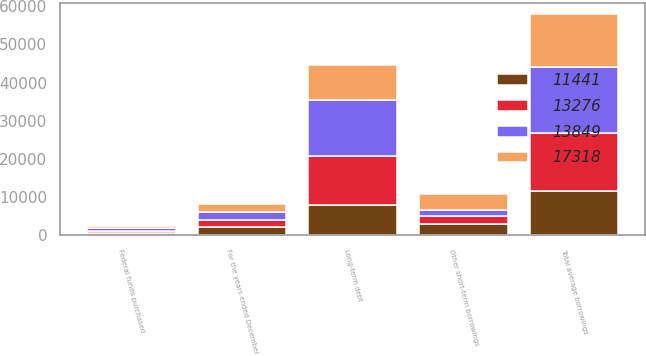Convert chart to OTSL. <chart><loc_0><loc_0><loc_500><loc_500><stacked_bar_chart><ecel><fcel>For the years ended December<fcel>Federal funds purchased<fcel>Other short-term borrowings<fcel>Long-term debt<fcel>Total average borrowings<nl><fcel>13849<fcel>2015<fcel>920<fcel>1721<fcel>14677<fcel>17318<nl><fcel>13276<fcel>2014<fcel>458<fcel>1873<fcel>12928<fcel>15259<nl><fcel>11441<fcel>2013<fcel>503<fcel>3024<fcel>7914<fcel>11441<nl><fcel>17318<fcel>2012<fcel>560<fcel>4246<fcel>9043<fcel>13849<nl></chart> 